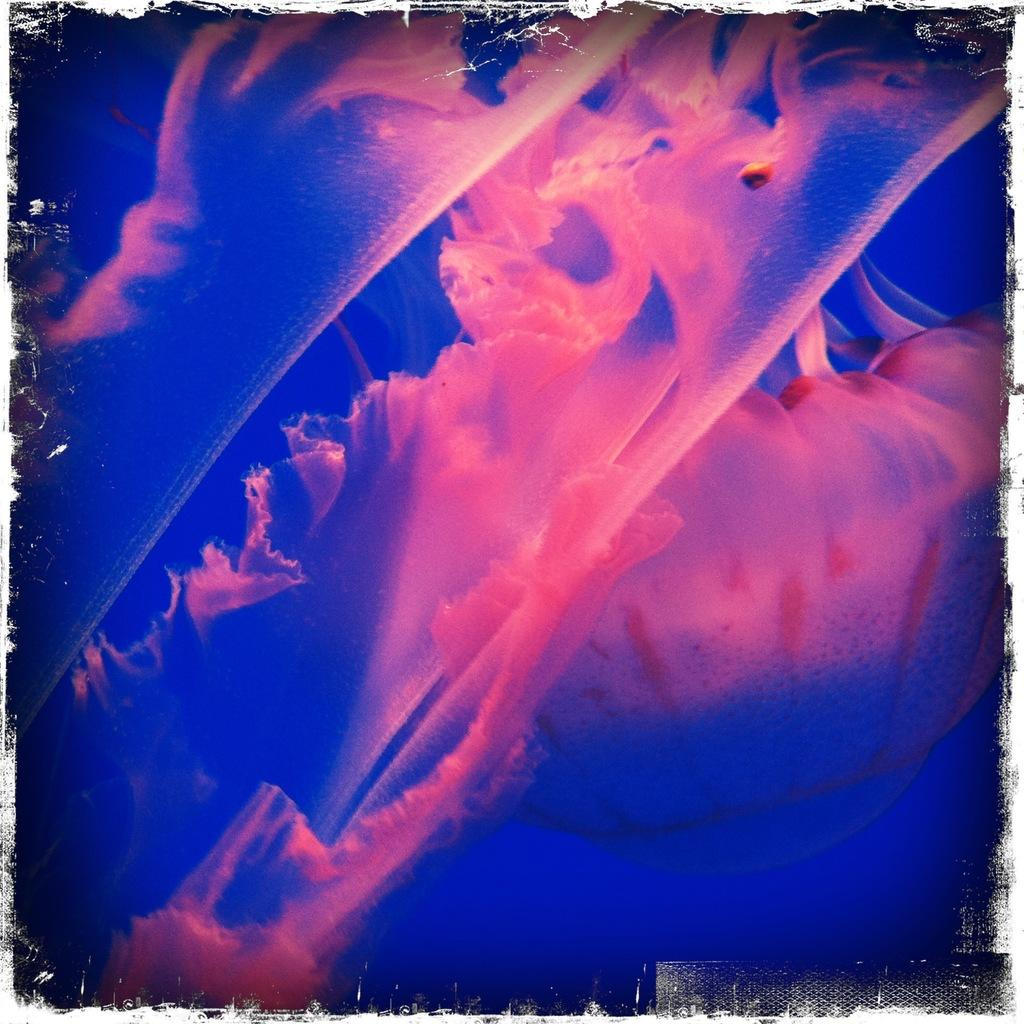What is the main subject of the image? There is a painting in the image. What colors are present in the painting? The painting has pink and blue colors. Where is the tramp located in the image? There is no tramp present in the image; it features a painting with pink and blue colors. What type of heart is depicted in the painting? There is no heart depicted in the painting; it only has pink and blue colors. 